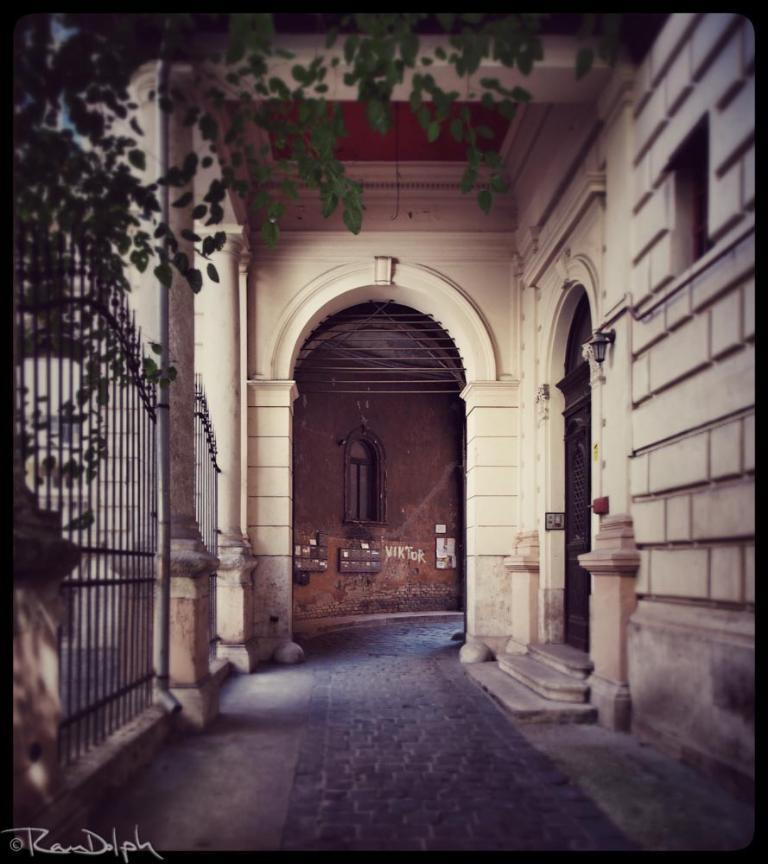Could you give a brief overview of what you see in this image? In this image I can see a wall, door and a window. Here I can see a fence and a tree. I can also see a watermark over here. 